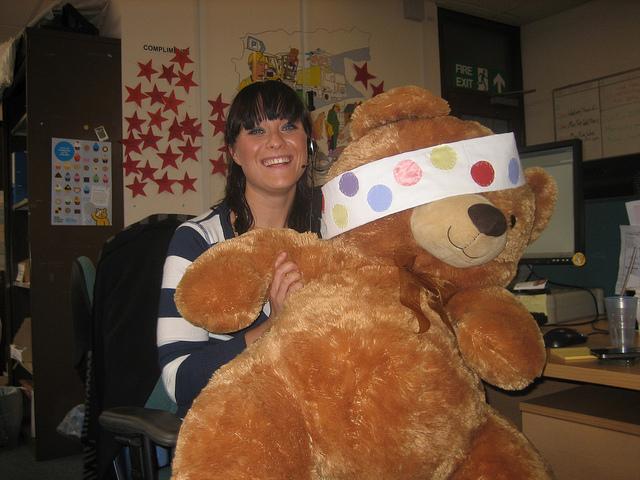Is the teddy bear covered one eye with a colorful ribbon?
Concise answer only. Yes. What color is the teddy bear?
Give a very brief answer. Brown. Where does it say FIRE EXIT?
Quick response, please. Top right. 